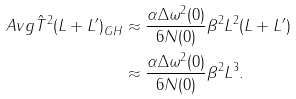<formula> <loc_0><loc_0><loc_500><loc_500>\ A v g { \hat { T } ^ { 2 } ( L + L ^ { \prime } ) } _ { G H } & \approx \frac { \alpha \Delta \omega ^ { 2 } ( 0 ) } { 6 N ( 0 ) } \beta ^ { 2 } L ^ { 2 } ( L + L ^ { \prime } ) \\ & \approx \frac { \alpha \Delta \omega ^ { 2 } ( 0 ) } { 6 N ( 0 ) } \beta ^ { 2 } L ^ { 3 } .</formula> 